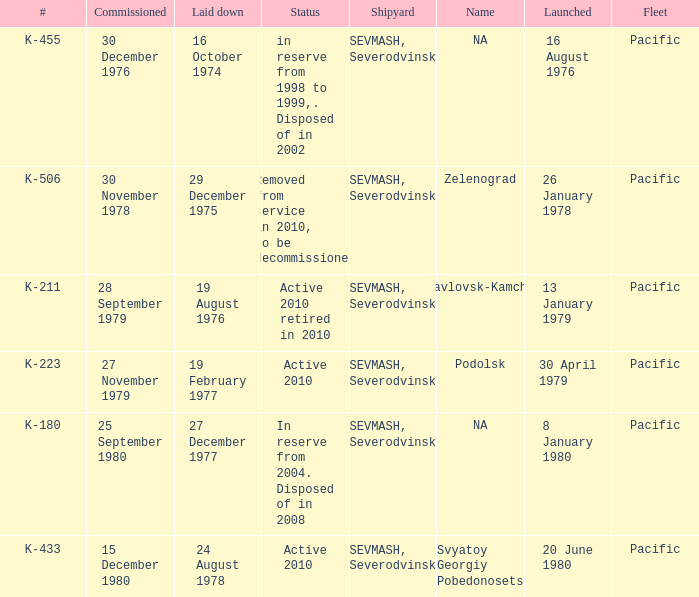What is the status of vessel number K-223? Active 2010. 